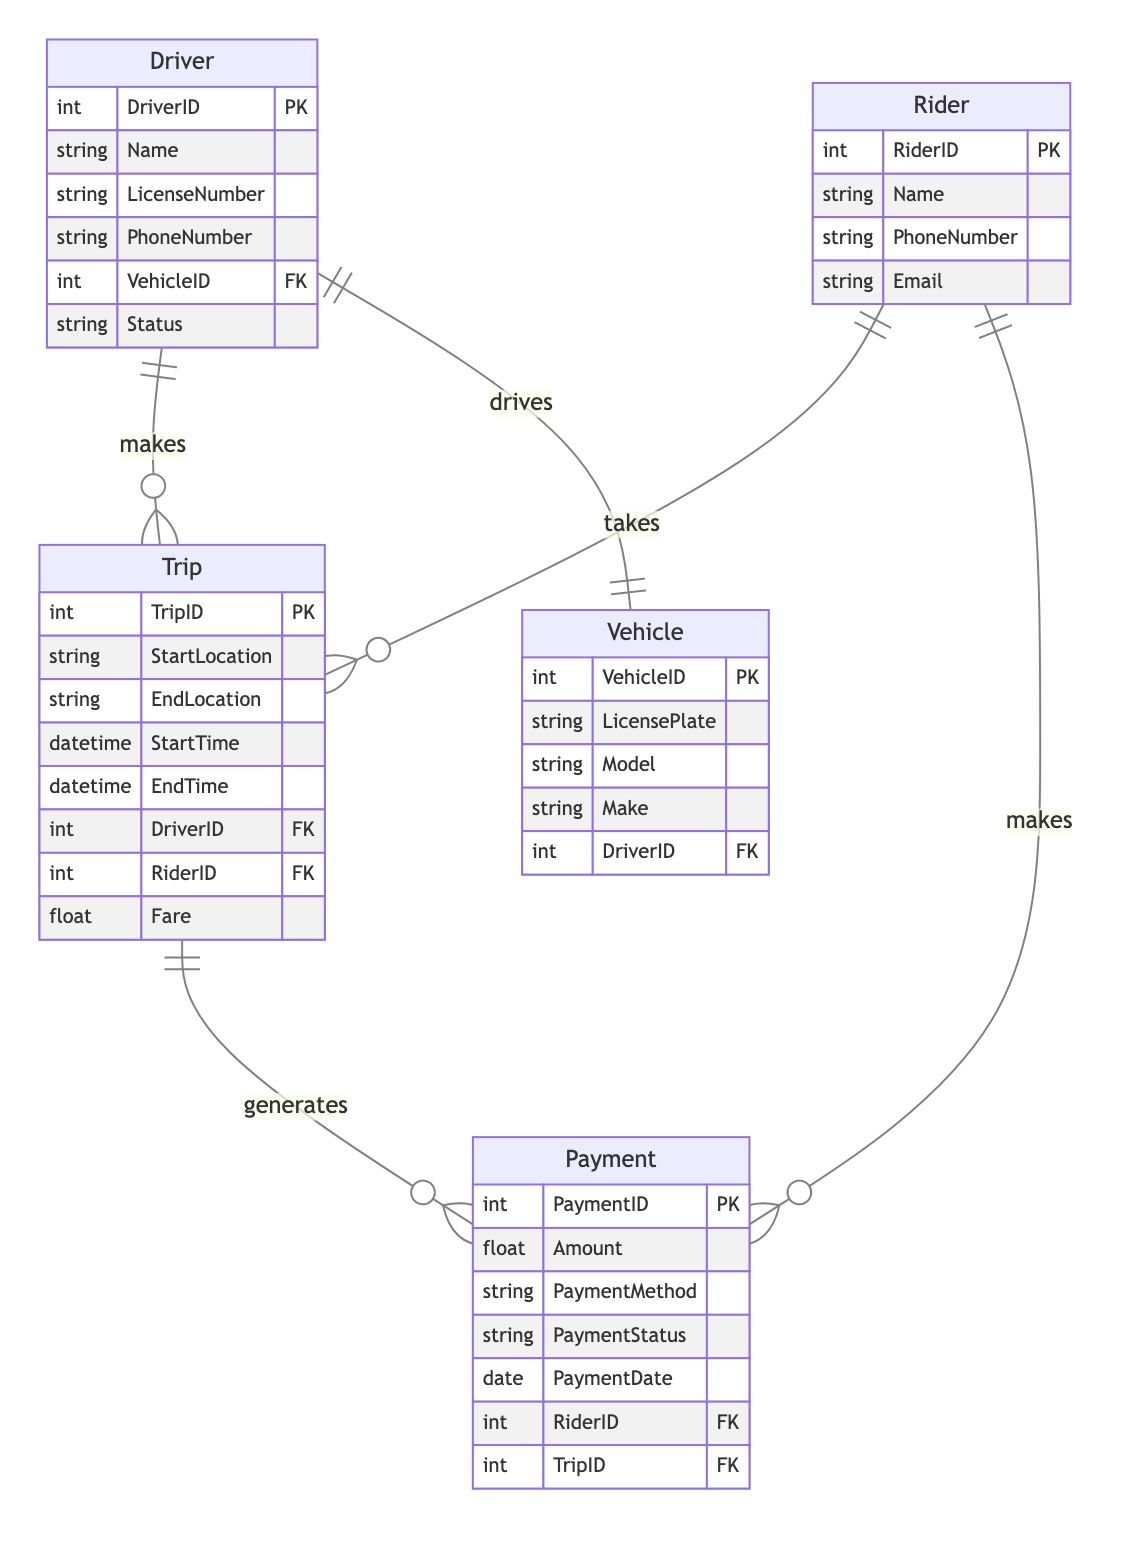What is the primary key of the Driver entity? The primary key of the Driver entity is DriverID, as indicated in the diagram where it is marked with PK.
Answer: DriverID How many entities are present in the diagram? The diagram includes five entities: Driver, Rider, Vehicle, Trip, and Payment. Counting these gives a total of five entities.
Answer: 5 What type of relationship exists between Driver and Trip? The relationship between Driver and Trip is a one-to-many (1:M) relationship, meaning one Driver can have multiple Trips. This is indicated in the relationship section of the diagram.
Answer: 1:M What attributes are included in the Payment entity? The Payment entity includes the attributes: PaymentID, Amount, PaymentMethod, PaymentStatus, PaymentDate, RiderID, and TripID, as specified in the diagram.
Answer: PaymentID, Amount, PaymentMethod, PaymentStatus, PaymentDate, RiderID, TripID If a Rider takes multiple Trips, what is the nature of the Rider-Trip relationship? The Rider-Trip relationship is a one-to-many (1:M) relationship, which means a single Rider can be associated with multiple Trips, as shown in the relationship notation.
Answer: 1:M Which entity is directly related to the Vehicle entity? The Vehicle entity is directly related to the Driver entity through a one-to-one (1:1) relationship, indicating that each Vehicle is driven by one Driver. This is explicitly stated in the relationship section.
Answer: Driver How many attributes does the Trip entity have? The Trip entity has seven attributes: TripID, StartLocation, EndLocation, StartTime, EndTime, DriverID, and RiderID. By counting these from the attributes list in the diagram, the total is seven.
Answer: 7 What entities are involved in generating a Payment? A Payment is generated from a Trip, and it is also associated with a Rider. The relationship shows that both Trip and Rider are involved in generating a Payment.
Answer: Trip, Rider What is the relationship type between the Trip and Payment entities? The relationship type between the Trip and Payment entities is one-to-many (1:M), indicating that a single Trip can generate multiple Payments. This relationship is clearly indicated in the relationship description.
Answer: 1:M 